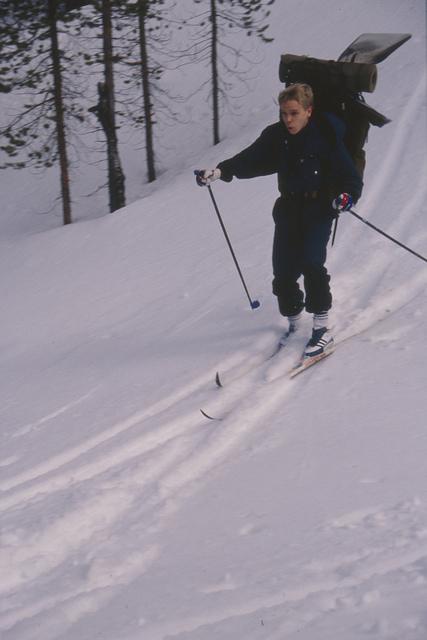How many trees are in the background?
Concise answer only. 4. What does he have on his eyes?
Give a very brief answer. Nothing. Do his pants fit?
Write a very short answer. Yes. Does the lady have a shadow?
Answer briefly. No. What does this boy have on his face?
Answer briefly. Nothing. How many trees are in the photo?
Be succinct. 4. Is this man skiing for fun?
Keep it brief. Yes. Is he standing?
Quick response, please. Yes. Is it cold in the image?
Be succinct. Yes. Is the skier easily carrying his gear, or is he struggling?
Answer briefly. Struggling. Is the person skiing wearing purple?
Short answer required. No. 